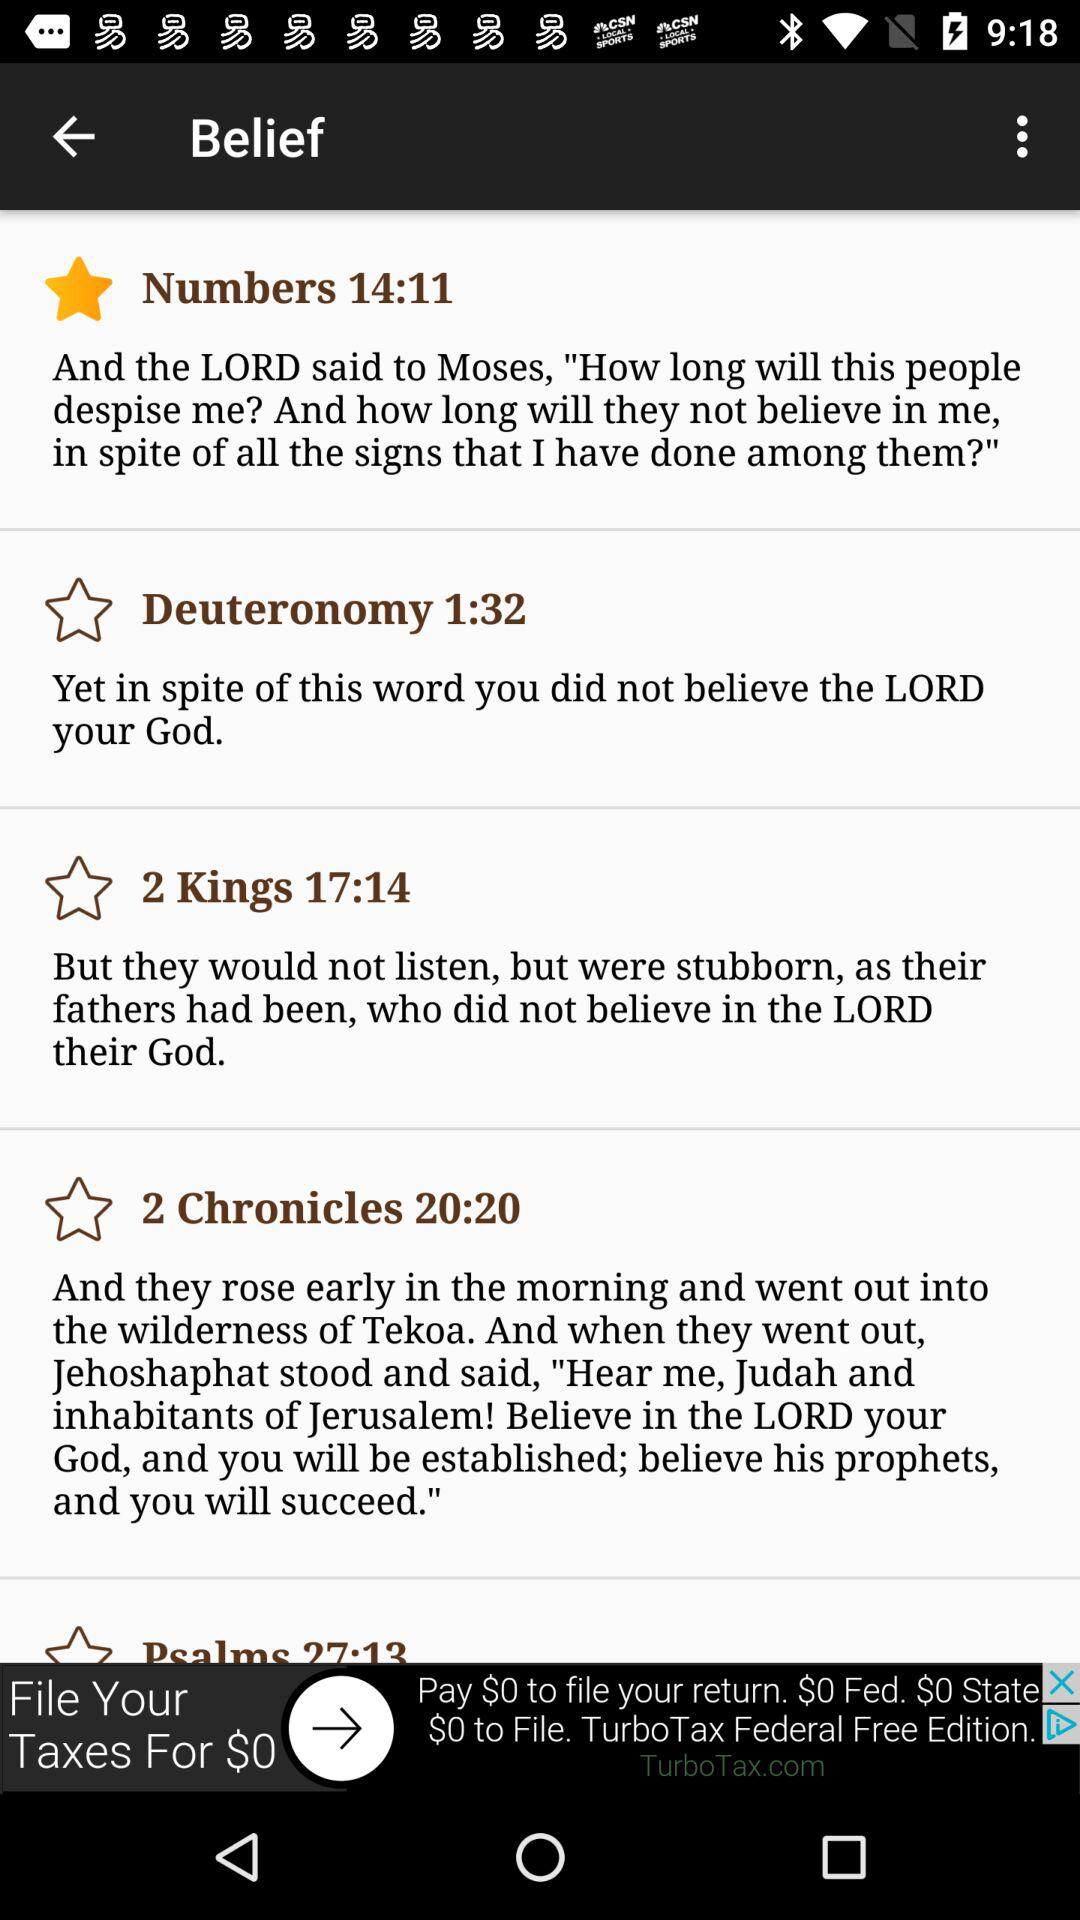What option is selected in the application? The selected option is "Numbers 14:11". 